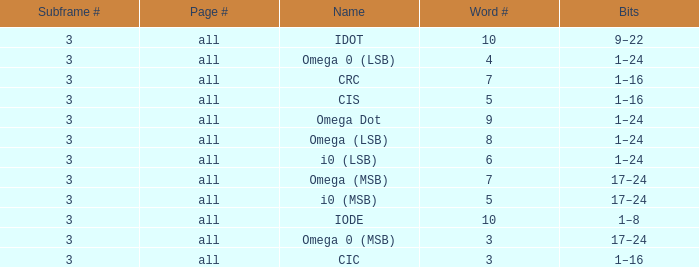What is the word count that is named omega dot? 9.0. 